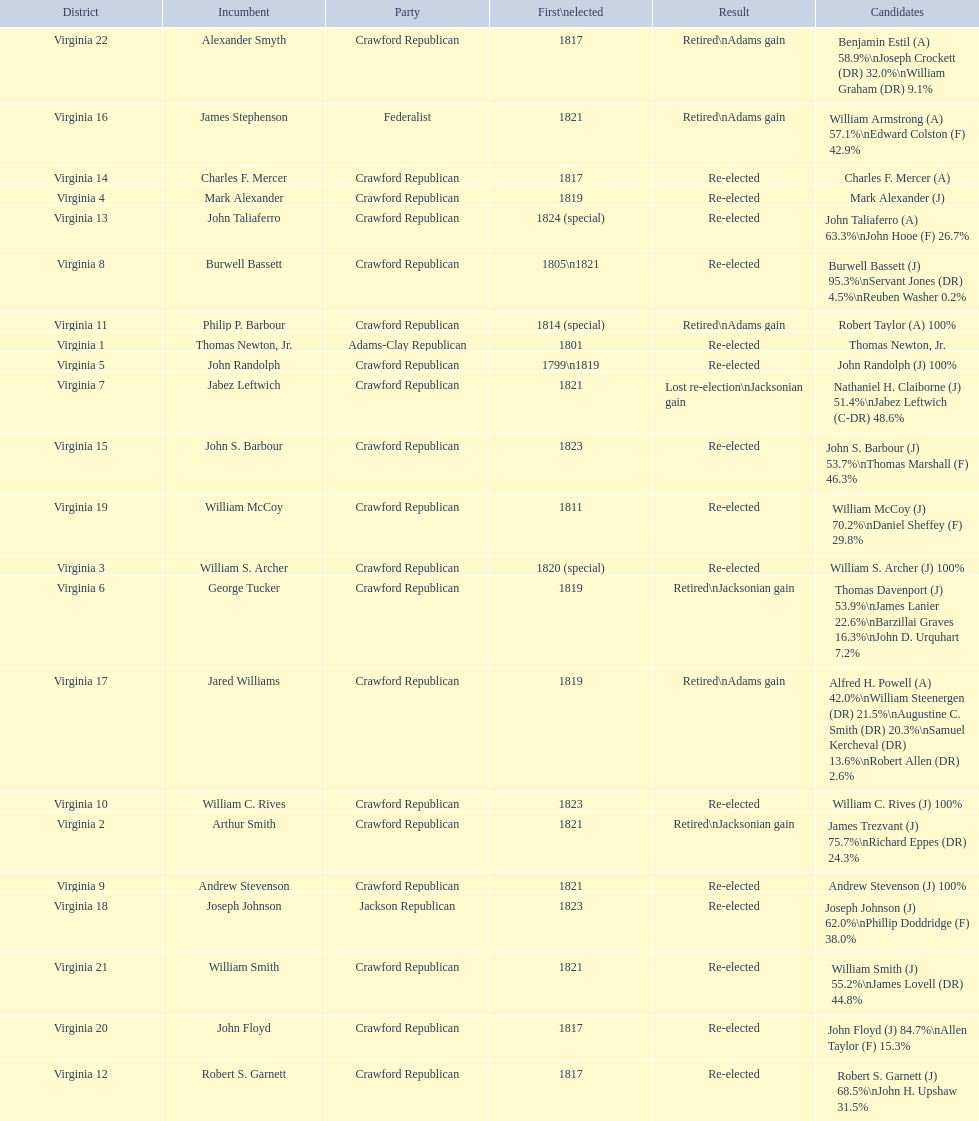Name the only candidate that was first elected in 1811. William McCoy. 